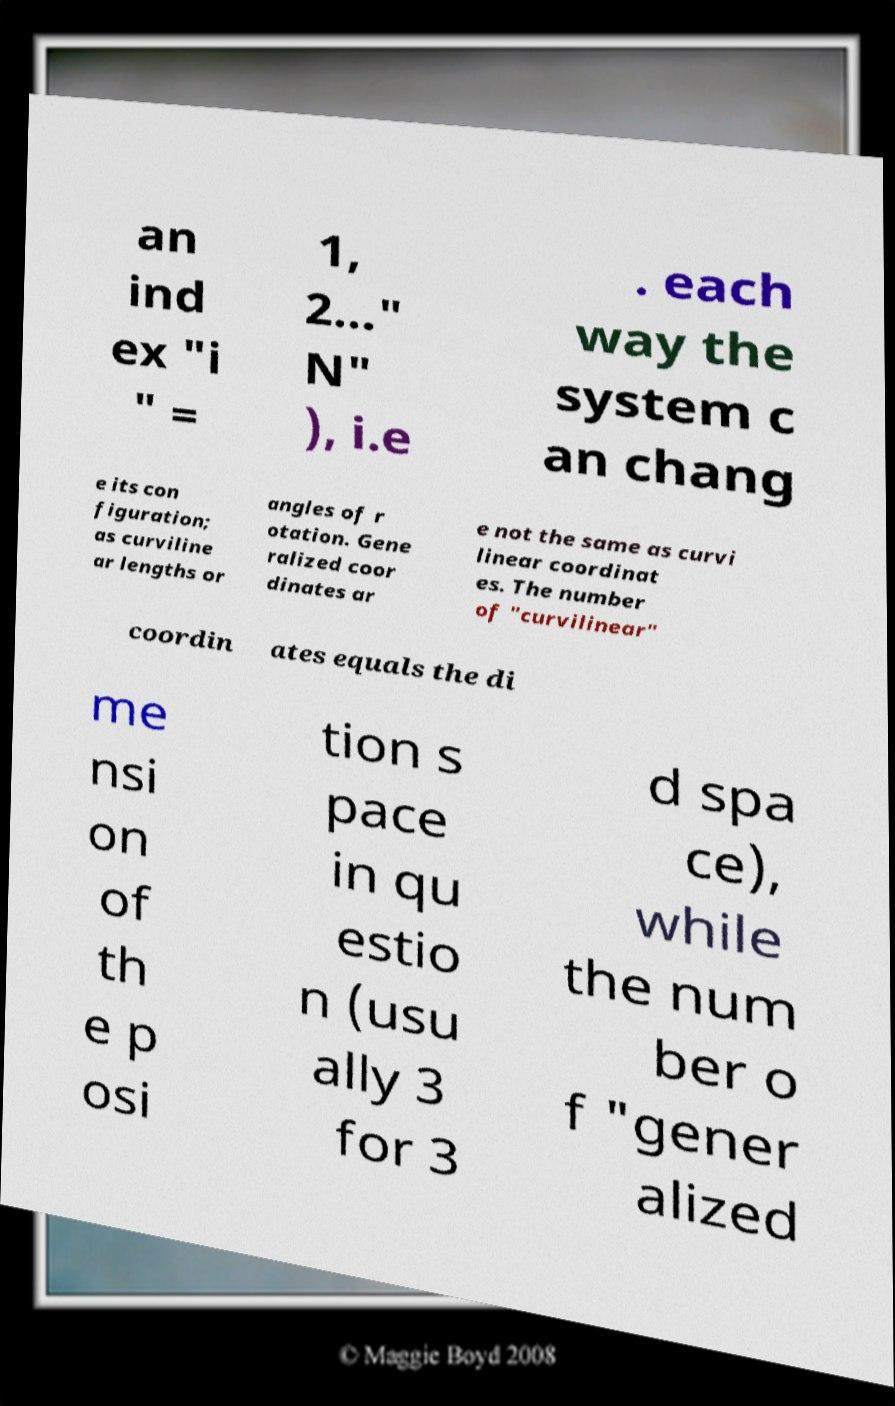Can you accurately transcribe the text from the provided image for me? an ind ex "i " = 1, 2..." N" ), i.e . each way the system c an chang e its con figuration; as curviline ar lengths or angles of r otation. Gene ralized coor dinates ar e not the same as curvi linear coordinat es. The number of "curvilinear" coordin ates equals the di me nsi on of th e p osi tion s pace in qu estio n (usu ally 3 for 3 d spa ce), while the num ber o f "gener alized 